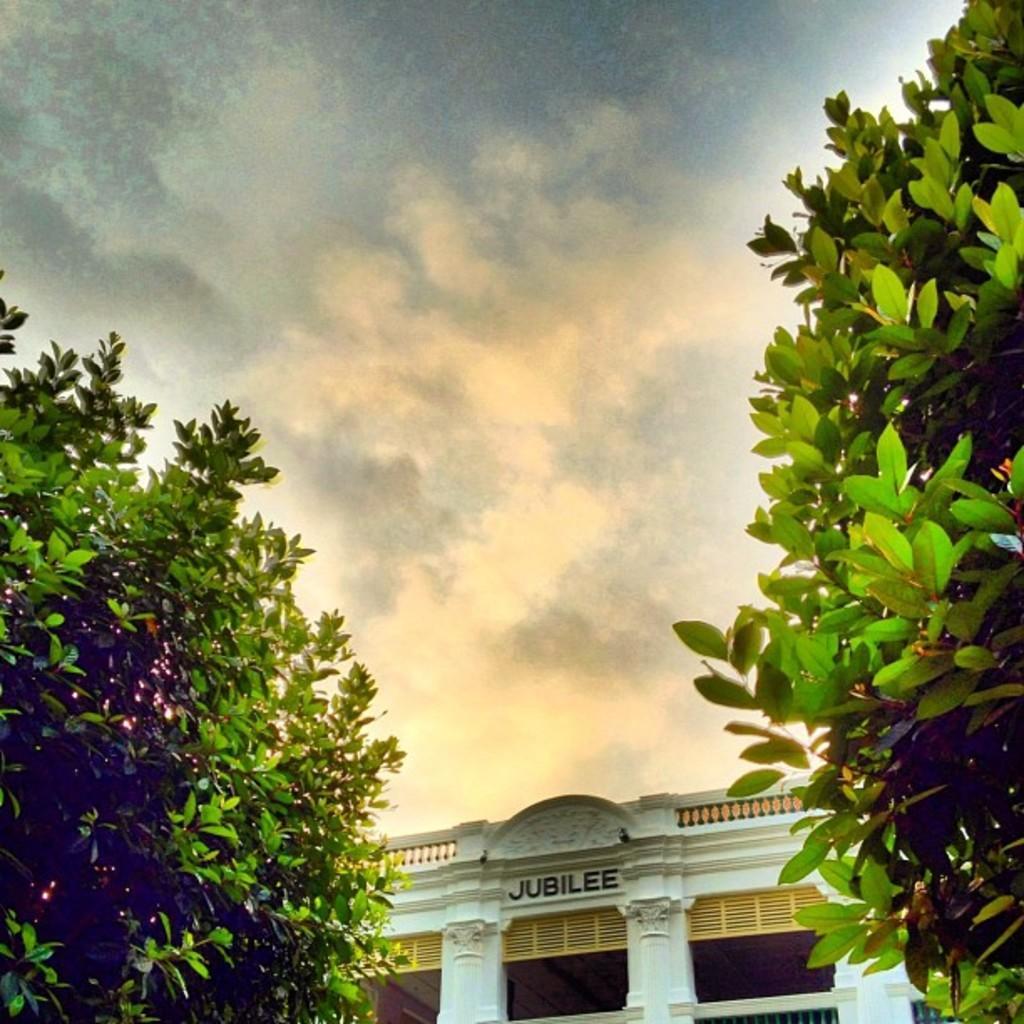Can you describe this image briefly? On the right side and left side of the image, we can see plants. At the bottom of the image, we can see the building with text, pillars, wall and railings. We can see the cloudy sky in the background. 